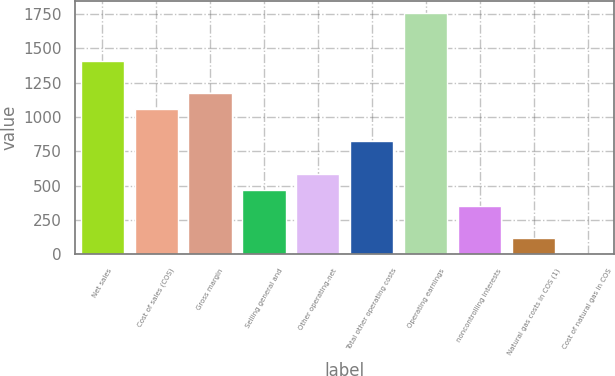Convert chart to OTSL. <chart><loc_0><loc_0><loc_500><loc_500><bar_chart><fcel>Net sales<fcel>Cost of sales (COS)<fcel>Gross margin<fcel>Selling general and<fcel>Other operating-net<fcel>Total other operating costs<fcel>Operating earnings<fcel>noncontrolling interests<fcel>Natural gas costs in COS (1)<fcel>Cost of natural gas in COS<nl><fcel>1407.46<fcel>1055.83<fcel>1173.04<fcel>469.78<fcel>586.99<fcel>821.41<fcel>1759.09<fcel>352.57<fcel>118.15<fcel>0.94<nl></chart> 